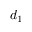Convert formula to latex. <formula><loc_0><loc_0><loc_500><loc_500>d _ { 1 }</formula> 